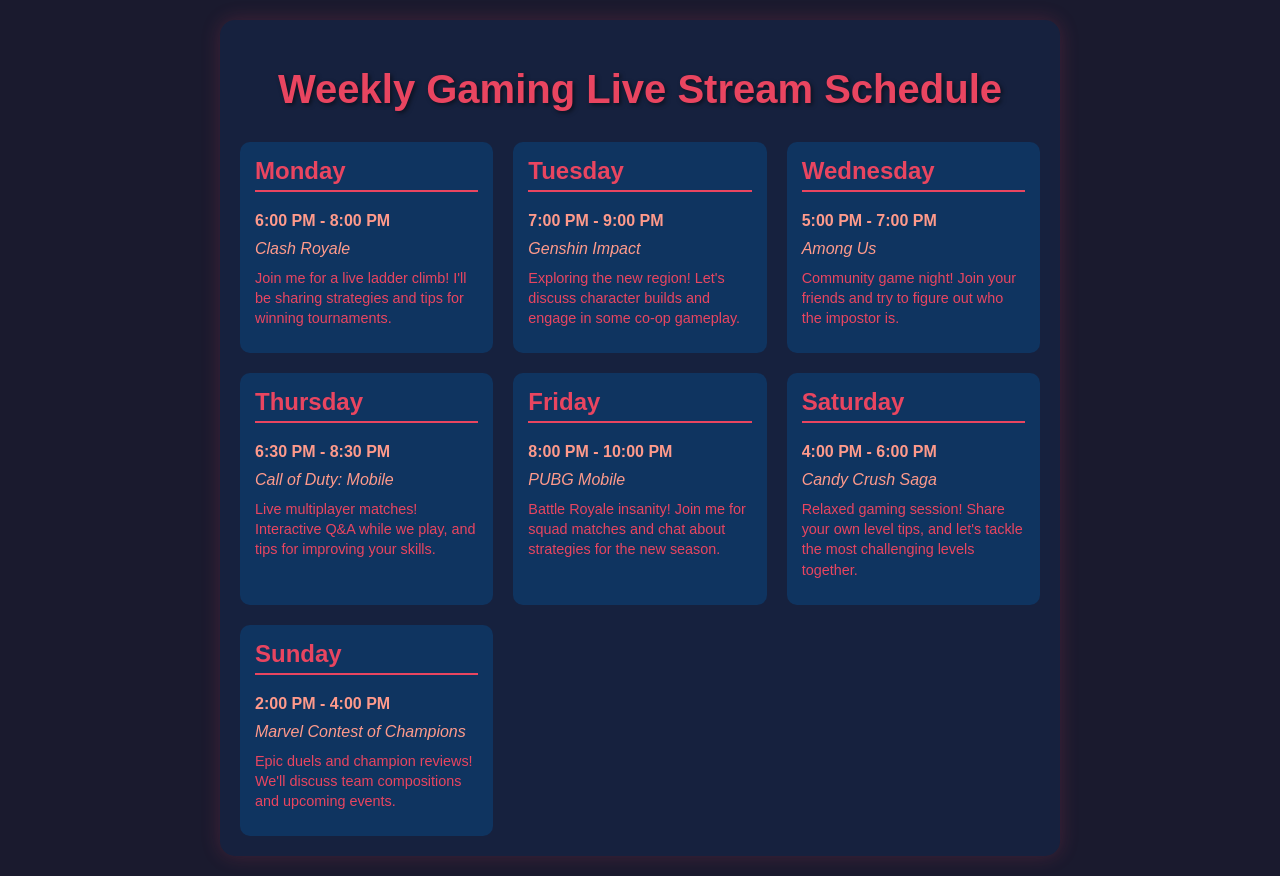What game is scheduled for Monday? The game scheduled for Monday is mentioned in the document under the corresponding day, which is Clash Royale.
Answer: Clash Royale What time does the Thursday livestream start? The document specifies that the Thursday livestream starts at 6:30 PM.
Answer: 6:30 PM How long is the Friday gaming session? The document indicates that the Friday gaming session lasts for 2 hours, from 8:00 PM to 10:00 PM.
Answer: 2 hours Which game is played during the Wednesday session? The game listed for the Wednesday session is Among Us, as per the schedule provided in the document.
Answer: Among Us What is the planned game for Saturday? The game planned for Saturday, according to the schedule in the document, is Candy Crush Saga.
Answer: Candy Crush Saga On which day is the Q&A session scheduled? The Q&A session is mentioned for Thursday during the Call of Duty: Mobile session, indicating interaction with viewers.
Answer: Thursday What is the theme of the Sunday livestream? The theme of the Sunday livestream involves discussing champion reviews and duels in the specified game, which is Marvel Contest of Champions.
Answer: Epic duels and champion reviews What time frame is allocated for the Tuesday stream? The document states that the Tuesday stream runs from 7:00 PM to 9:00 PM, giving the specific time frame.
Answer: 7:00 PM - 9:00 PM What is the purpose of the Monday stream? The document indicates that the Monday stream focuses on sharing strategies and tips for winning tournaments in Clash Royale.
Answer: Live ladder climb and strategies 